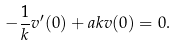Convert formula to latex. <formula><loc_0><loc_0><loc_500><loc_500>- { \frac { 1 } { k } } v ^ { \prime } ( 0 ) + a k v ( 0 ) = 0 .</formula> 